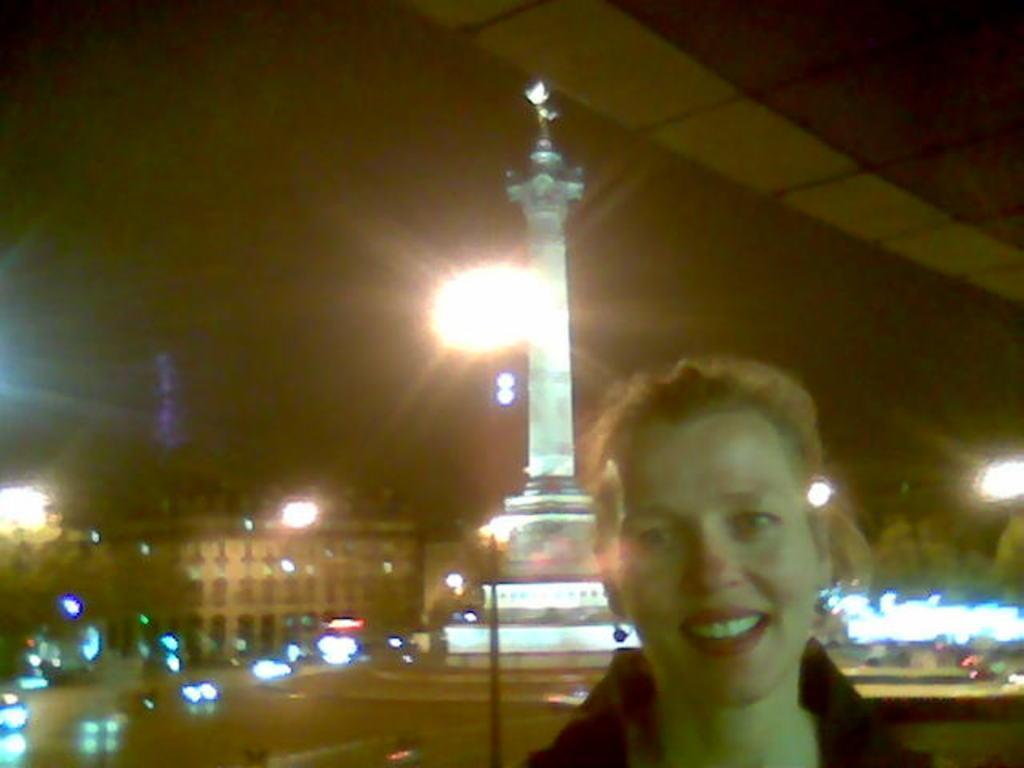In one or two sentences, can you explain what this image depicts? In this image we can see a person, behind her there is a white color statue, also we can see there are some buildings and lights. 